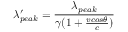Convert formula to latex. <formula><loc_0><loc_0><loc_500><loc_500>\lambda _ { p e a k } ^ { \prime } = \frac { \lambda _ { p e a k } } { \gamma ( 1 + \frac { v \cos \theta } { c } ) }</formula> 